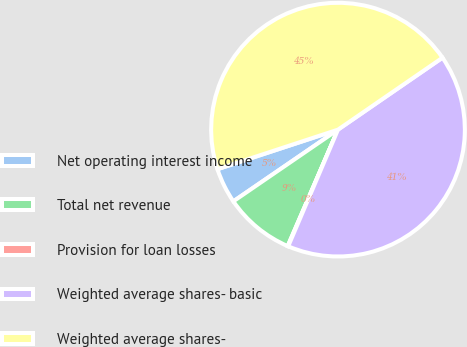Convert chart. <chart><loc_0><loc_0><loc_500><loc_500><pie_chart><fcel>Net operating interest income<fcel>Total net revenue<fcel>Provision for loan losses<fcel>Weighted average shares- basic<fcel>Weighted average shares-<nl><fcel>4.51%<fcel>8.95%<fcel>0.07%<fcel>41.02%<fcel>45.46%<nl></chart> 